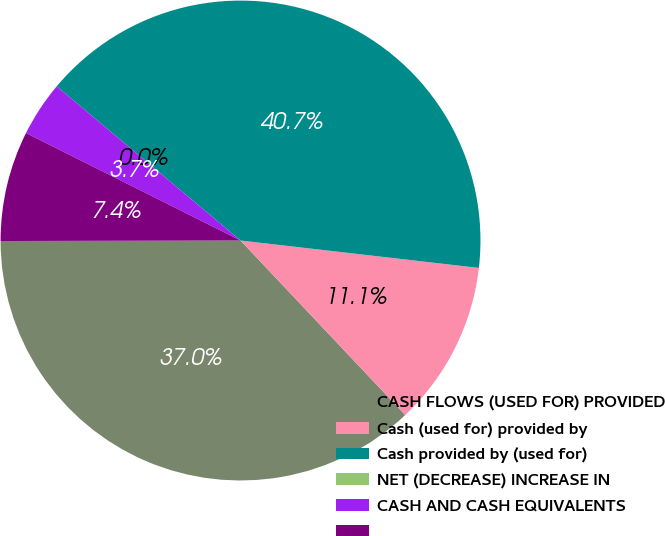Convert chart. <chart><loc_0><loc_0><loc_500><loc_500><pie_chart><fcel>CASH FLOWS (USED FOR) PROVIDED<fcel>Cash (used for) provided by<fcel>Cash provided by (used for)<fcel>NET (DECREASE) INCREASE IN<fcel>CASH AND CASH EQUIVALENTS<fcel>Unnamed: 5<nl><fcel>37.01%<fcel>11.14%<fcel>40.72%<fcel>0.0%<fcel>3.71%<fcel>7.43%<nl></chart> 